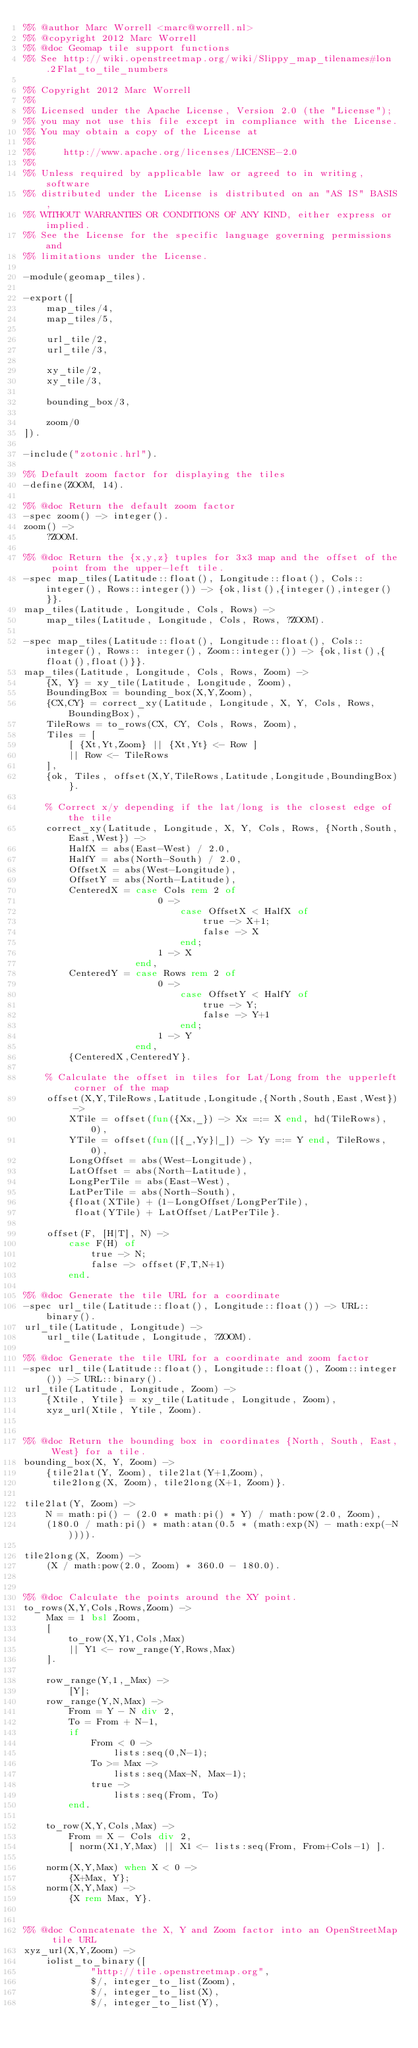<code> <loc_0><loc_0><loc_500><loc_500><_Erlang_>%% @author Marc Worrell <marc@worrell.nl>
%% @copyright 2012 Marc Worrell
%% @doc Geomap tile support functions
%% See http://wiki.openstreetmap.org/wiki/Slippy_map_tilenames#lon.2Flat_to_tile_numbers

%% Copyright 2012 Marc Worrell
%%
%% Licensed under the Apache License, Version 2.0 (the "License");
%% you may not use this file except in compliance with the License.
%% You may obtain a copy of the License at
%%
%%     http://www.apache.org/licenses/LICENSE-2.0
%%
%% Unless required by applicable law or agreed to in writing, software
%% distributed under the License is distributed on an "AS IS" BASIS,
%% WITHOUT WARRANTIES OR CONDITIONS OF ANY KIND, either express or implied.
%% See the License for the specific language governing permissions and
%% limitations under the License.

-module(geomap_tiles).

-export([
    map_tiles/4,
    map_tiles/5,

    url_tile/2,
    url_tile/3,

    xy_tile/2,
    xy_tile/3,

    bounding_box/3,

    zoom/0
]).

-include("zotonic.hrl").

%% Default zoom factor for displaying the tiles
-define(ZOOM, 14).

%% @doc Return the default zoom factor
-spec zoom() -> integer().
zoom() ->
    ?ZOOM.

%% @doc Return the {x,y,z} tuples for 3x3 map and the offset of the point from the upper-left tile.
-spec map_tiles(Latitude::float(), Longitude::float(), Cols::integer(), Rows::integer()) -> {ok,list(),{integer(),integer()}}.
map_tiles(Latitude, Longitude, Cols, Rows) ->
    map_tiles(Latitude, Longitude, Cols, Rows, ?ZOOM).

-spec map_tiles(Latitude::float(), Longitude::float(), Cols::integer(), Rows:: integer(), Zoom::integer()) -> {ok,list(),{float(),float()}}.
map_tiles(Latitude, Longitude, Cols, Rows, Zoom) ->
    {X, Y} = xy_tile(Latitude, Longitude, Zoom),
    BoundingBox = bounding_box(X,Y,Zoom),
    {CX,CY} = correct_xy(Latitude, Longitude, X, Y, Cols, Rows, BoundingBox),
    TileRows = to_rows(CX, CY, Cols, Rows, Zoom),
    Tiles = [
        [ {Xt,Yt,Zoom} || {Xt,Yt} <- Row ]
        || Row <- TileRows
    ],
    {ok, Tiles, offset(X,Y,TileRows,Latitude,Longitude,BoundingBox)}.

    % Correct x/y depending if the lat/long is the closest edge of the tile
    correct_xy(Latitude, Longitude, X, Y, Cols, Rows, {North,South,East,West}) ->
        HalfX = abs(East-West) / 2.0,
        HalfY = abs(North-South) / 2.0,
        OffsetX = abs(West-Longitude),
        OffsetY = abs(North-Latitude),
        CenteredX = case Cols rem 2 of
                        0 ->
                            case OffsetX < HalfX of
                                true -> X+1;
                                false -> X
                            end;
                        1 -> X
                    end,
        CenteredY = case Rows rem 2 of
                        0 ->
                            case OffsetY < HalfY of
                                true -> Y;
                                false -> Y+1
                            end;
                        1 -> Y
                    end,
        {CenteredX,CenteredY}.

    % Calculate the offset in tiles for Lat/Long from the upperleft corner of the map
    offset(X,Y,TileRows,Latitude,Longitude,{North,South,East,West}) ->
        XTile = offset(fun({Xx,_}) -> Xx =:= X end, hd(TileRows), 0),
        YTile = offset(fun([{_,Yy}|_]) -> Yy =:= Y end, TileRows, 0),
        LongOffset = abs(West-Longitude),
        LatOffset = abs(North-Latitude),
        LongPerTile = abs(East-West),
        LatPerTile = abs(North-South),
        {float(XTile) + (1-LongOffset/LongPerTile),
         float(YTile) + LatOffset/LatPerTile}.

    offset(F, [H|T], N) ->
        case F(H) of
            true -> N;
            false -> offset(F,T,N+1)
        end.

%% @doc Generate the tile URL for a coordinate
-spec url_tile(Latitude::float(), Longitude::float()) -> URL::binary().
url_tile(Latitude, Longitude) ->
    url_tile(Latitude, Longitude, ?ZOOM).

%% @doc Generate the tile URL for a coordinate and zoom factor
-spec url_tile(Latitude::float(), Longitude::float(), Zoom::integer()) -> URL::binary().
url_tile(Latitude, Longitude, Zoom) ->
    {Xtile, Ytile} = xy_tile(Latitude, Longitude, Zoom),
    xyz_url(Xtile, Ytile, Zoom).


%% @doc Return the bounding box in coordinates {North, South, East, West} for a tile.
bounding_box(X, Y, Zoom) ->
    {tile2lat(Y, Zoom), tile2lat(Y+1,Zoom),
     tile2long(X, Zoom), tile2long(X+1, Zoom)}.

tile2lat(Y, Zoom) ->
    N = math:pi() - (2.0 * math:pi() * Y) / math:pow(2.0, Zoom),
    (180.0 / math:pi() * math:atan(0.5 * (math:exp(N) - math:exp(-N)))).

tile2long(X, Zoom) ->
    (X / math:pow(2.0, Zoom) * 360.0 - 180.0).


%% @doc Calculate the points around the XY point.
to_rows(X,Y,Cols,Rows,Zoom) ->
    Max = 1 bsl Zoom,
    [
        to_row(X,Y1,Cols,Max)
        || Y1 <- row_range(Y,Rows,Max)
    ].

    row_range(Y,1,_Max) ->
        [Y];
    row_range(Y,N,Max) ->
        From = Y - N div 2,
        To = From + N-1,
        if
            From < 0 ->
                lists:seq(0,N-1);
            To >= Max ->
                lists:seq(Max-N, Max-1);
            true ->
                lists:seq(From, To)
        end.

    to_row(X,Y,Cols,Max) ->
        From = X - Cols div 2,
        [ norm(X1,Y,Max) || X1 <- lists:seq(From, From+Cols-1) ].

    norm(X,Y,Max) when X < 0 ->
        {X+Max, Y};
    norm(X,Y,Max) ->
        {X rem Max, Y}.


%% @doc Conncatenate the X, Y and Zoom factor into an OpenStreetMap tile URL
xyz_url(X,Y,Zoom) ->
    iolist_to_binary([
            "http://tile.openstreetmap.org",
            $/, integer_to_list(Zoom),
            $/, integer_to_list(X),
            $/, integer_to_list(Y),</code> 